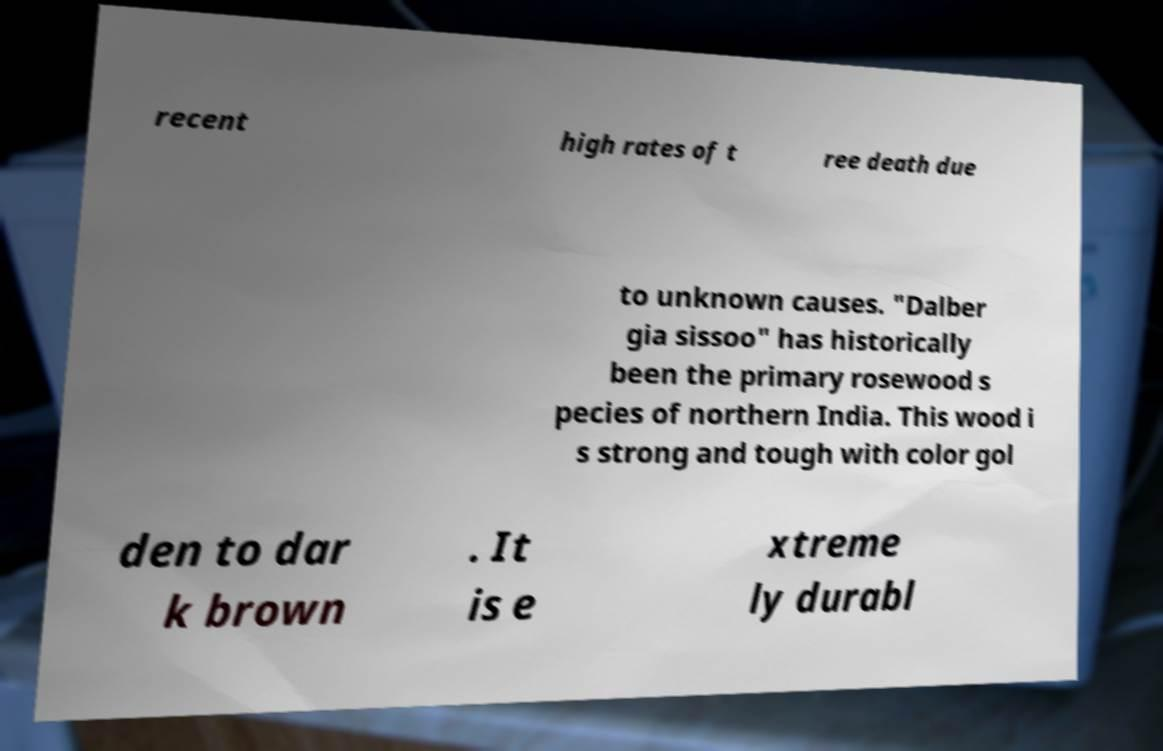Can you read and provide the text displayed in the image?This photo seems to have some interesting text. Can you extract and type it out for me? recent high rates of t ree death due to unknown causes. "Dalber gia sissoo" has historically been the primary rosewood s pecies of northern India. This wood i s strong and tough with color gol den to dar k brown . It is e xtreme ly durabl 